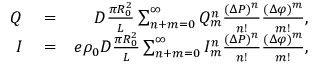Convert formula to latex. <formula><loc_0><loc_0><loc_500><loc_500>\begin{array} { r l r } { Q } & = } & { D \frac { \pi R _ { 0 } ^ { 2 } } { L } \sum _ { n + m = 0 } ^ { \infty } Q _ { m } ^ { n } \frac { ( \Delta P ) ^ { n } } { n ! } \frac { ( \Delta \varphi ) ^ { m } } { m ! } , } \\ { I } & = } & { e \rho _ { 0 } D \frac { \pi R _ { 0 } ^ { 2 } } { L } \sum _ { n + m = 0 } ^ { \infty } I _ { m } ^ { n } \frac { ( \Delta P ) ^ { n } } { n ! } \frac { ( \Delta \varphi ) ^ { m } } { m ! } , } \end{array}</formula> 